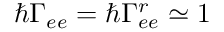<formula> <loc_0><loc_0><loc_500><loc_500>\hbar { \Gamma } _ { e e } = \hbar { \Gamma } _ { e e } ^ { r } \simeq 1</formula> 